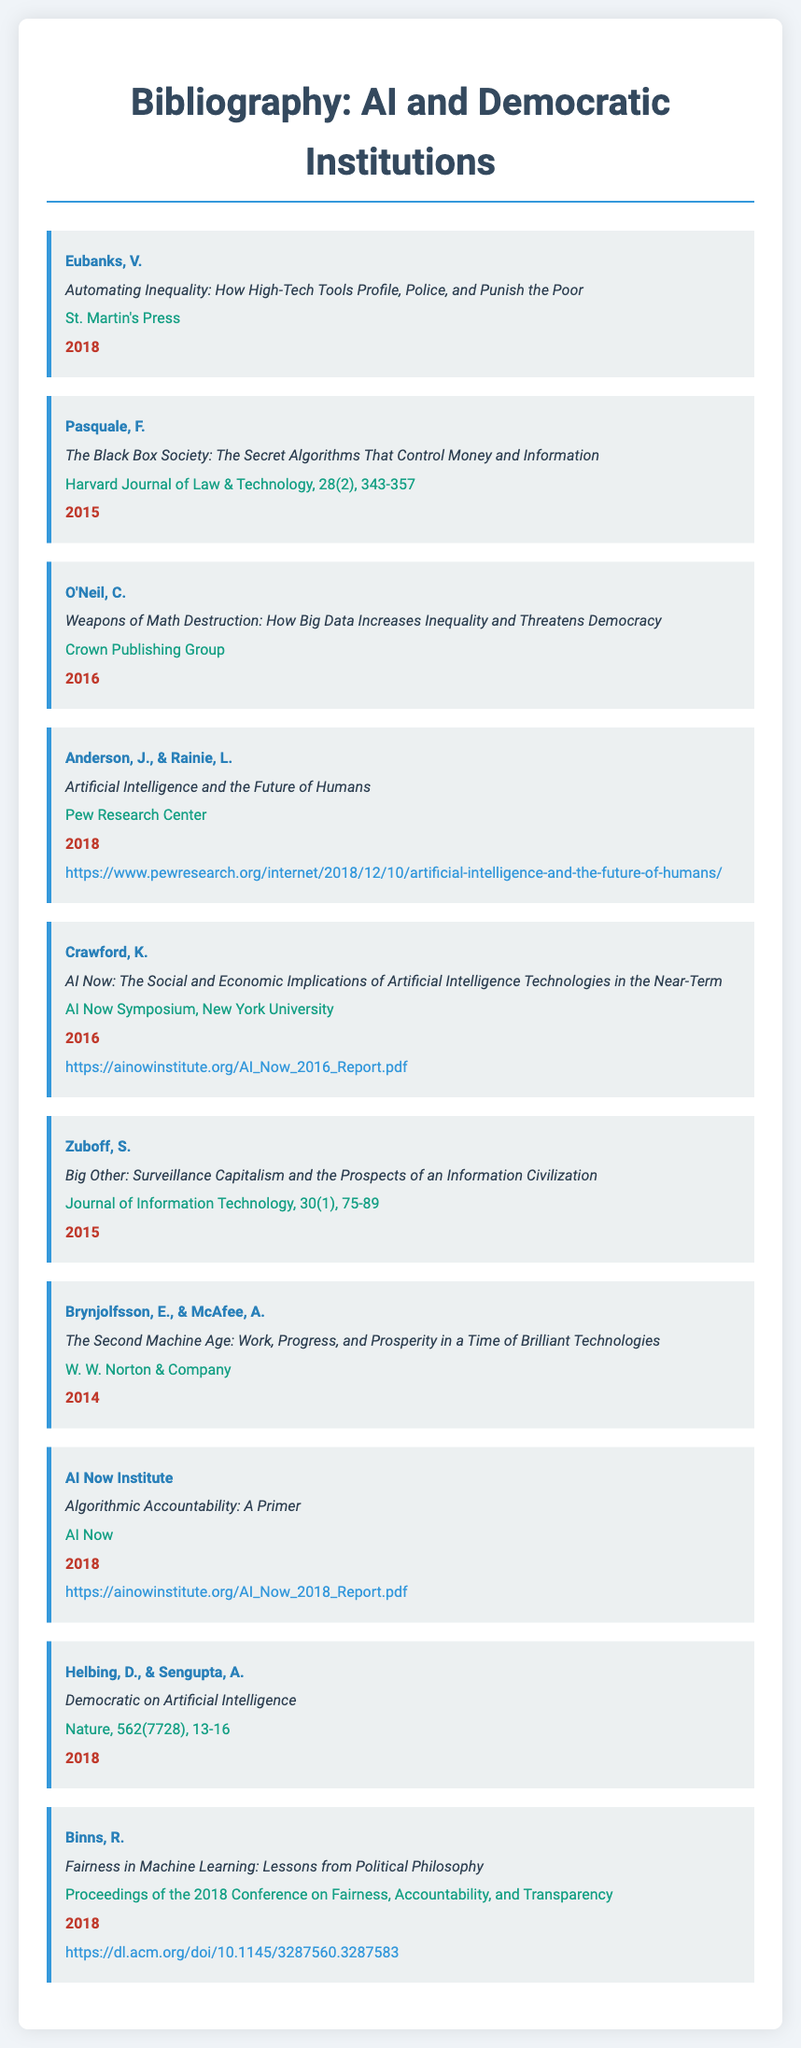what is the title of the book by Eubanks? The title of the book is listed in the document under Eubanks' bibliography item, which is "Automating Inequality: How High-Tech Tools Profile, Police, and Punish the Poor."
Answer: Automating Inequality: How High-Tech Tools Profile, Police, and Punish the Poor who is the author of "Weapons of Math Destruction"? The author is mentioned in the document as O'Neil, who wrote "Weapons of Math Destruction."
Answer: O'Neil what year was "The Black Box Society" published? The publication year is specified next to the title in the document, which is 2015.
Answer: 2015 which source published "Artificial Intelligence and the Future of Humans"? The source listed in the document for this title is the Pew Research Center.
Answer: Pew Research Center how many authors contributed to "Democratic on Artificial Intelligence"? The document lists authors associated with this work, which are Helbing and Sengupta, indicating there are two authors.
Answer: 2 what type of document is this? The structured information provided showcases a collection of references specifically related to AI and democratic institutions, categorized as a bibliography.
Answer: bibliography what is the main focus of the document? The main focus is illustrated through the titles and authors that address the intersection of AI with democratic processes and institutions.
Answer: AI and democratic institutions which item is published in the Journal of Information Technology? The title "Big Other: Surveillance Capitalism and the Prospects of an Information Civilization" is indicated as published in the Journal of Information Technology.
Answer: Big Other: Surveillance Capitalism and the Prospects of an Information Civilization 